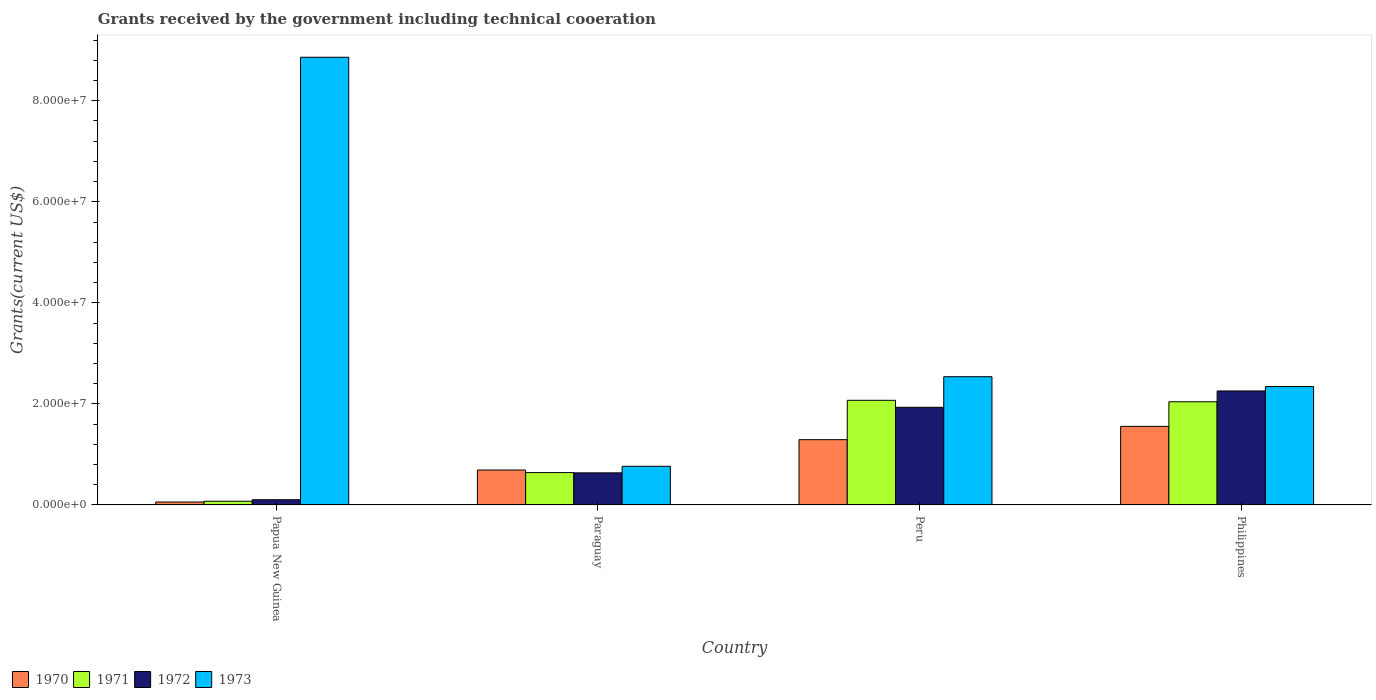How many different coloured bars are there?
Provide a succinct answer. 4. How many groups of bars are there?
Your answer should be very brief. 4. Are the number of bars per tick equal to the number of legend labels?
Your answer should be compact. Yes. How many bars are there on the 3rd tick from the right?
Offer a terse response. 4. What is the label of the 3rd group of bars from the left?
Ensure brevity in your answer.  Peru. What is the total grants received by the government in 1970 in Papua New Guinea?
Offer a terse response. 5.80e+05. Across all countries, what is the maximum total grants received by the government in 1973?
Offer a terse response. 8.86e+07. Across all countries, what is the minimum total grants received by the government in 1972?
Provide a succinct answer. 1.03e+06. In which country was the total grants received by the government in 1973 minimum?
Make the answer very short. Paraguay. What is the total total grants received by the government in 1970 in the graph?
Ensure brevity in your answer.  3.60e+07. What is the difference between the total grants received by the government in 1971 in Papua New Guinea and that in Paraguay?
Your response must be concise. -5.67e+06. What is the difference between the total grants received by the government in 1970 in Paraguay and the total grants received by the government in 1972 in Papua New Guinea?
Offer a terse response. 5.88e+06. What is the average total grants received by the government in 1971 per country?
Provide a short and direct response. 1.21e+07. What is the ratio of the total grants received by the government in 1970 in Paraguay to that in Peru?
Keep it short and to the point. 0.53. Is the total grants received by the government in 1973 in Paraguay less than that in Philippines?
Ensure brevity in your answer.  Yes. What is the difference between the highest and the second highest total grants received by the government in 1971?
Offer a very short reply. 1.43e+07. What is the difference between the highest and the lowest total grants received by the government in 1970?
Your response must be concise. 1.50e+07. Is the sum of the total grants received by the government in 1970 in Papua New Guinea and Peru greater than the maximum total grants received by the government in 1973 across all countries?
Ensure brevity in your answer.  No. What does the 2nd bar from the right in Paraguay represents?
Provide a succinct answer. 1972. Is it the case that in every country, the sum of the total grants received by the government in 1970 and total grants received by the government in 1971 is greater than the total grants received by the government in 1972?
Offer a terse response. Yes. How many countries are there in the graph?
Offer a very short reply. 4. Are the values on the major ticks of Y-axis written in scientific E-notation?
Give a very brief answer. Yes. Where does the legend appear in the graph?
Keep it short and to the point. Bottom left. How many legend labels are there?
Offer a very short reply. 4. What is the title of the graph?
Provide a short and direct response. Grants received by the government including technical cooeration. Does "1975" appear as one of the legend labels in the graph?
Provide a succinct answer. No. What is the label or title of the X-axis?
Provide a succinct answer. Country. What is the label or title of the Y-axis?
Give a very brief answer. Grants(current US$). What is the Grants(current US$) of 1970 in Papua New Guinea?
Your answer should be very brief. 5.80e+05. What is the Grants(current US$) of 1971 in Papua New Guinea?
Provide a short and direct response. 7.30e+05. What is the Grants(current US$) in 1972 in Papua New Guinea?
Ensure brevity in your answer.  1.03e+06. What is the Grants(current US$) of 1973 in Papua New Guinea?
Ensure brevity in your answer.  8.86e+07. What is the Grants(current US$) of 1970 in Paraguay?
Give a very brief answer. 6.91e+06. What is the Grants(current US$) of 1971 in Paraguay?
Your answer should be very brief. 6.40e+06. What is the Grants(current US$) in 1972 in Paraguay?
Ensure brevity in your answer.  6.35e+06. What is the Grants(current US$) in 1973 in Paraguay?
Provide a succinct answer. 7.65e+06. What is the Grants(current US$) of 1970 in Peru?
Your answer should be compact. 1.29e+07. What is the Grants(current US$) in 1971 in Peru?
Your answer should be compact. 2.07e+07. What is the Grants(current US$) in 1972 in Peru?
Your response must be concise. 1.93e+07. What is the Grants(current US$) in 1973 in Peru?
Keep it short and to the point. 2.54e+07. What is the Grants(current US$) of 1970 in Philippines?
Your response must be concise. 1.56e+07. What is the Grants(current US$) of 1971 in Philippines?
Ensure brevity in your answer.  2.04e+07. What is the Grants(current US$) in 1972 in Philippines?
Offer a very short reply. 2.26e+07. What is the Grants(current US$) of 1973 in Philippines?
Provide a succinct answer. 2.34e+07. Across all countries, what is the maximum Grants(current US$) in 1970?
Offer a terse response. 1.56e+07. Across all countries, what is the maximum Grants(current US$) in 1971?
Your answer should be very brief. 2.07e+07. Across all countries, what is the maximum Grants(current US$) of 1972?
Give a very brief answer. 2.26e+07. Across all countries, what is the maximum Grants(current US$) in 1973?
Your response must be concise. 8.86e+07. Across all countries, what is the minimum Grants(current US$) of 1970?
Keep it short and to the point. 5.80e+05. Across all countries, what is the minimum Grants(current US$) of 1971?
Offer a very short reply. 7.30e+05. Across all countries, what is the minimum Grants(current US$) in 1972?
Make the answer very short. 1.03e+06. Across all countries, what is the minimum Grants(current US$) in 1973?
Your answer should be compact. 7.65e+06. What is the total Grants(current US$) of 1970 in the graph?
Offer a terse response. 3.60e+07. What is the total Grants(current US$) of 1971 in the graph?
Your answer should be very brief. 4.83e+07. What is the total Grants(current US$) of 1972 in the graph?
Offer a very short reply. 4.93e+07. What is the total Grants(current US$) in 1973 in the graph?
Your answer should be compact. 1.45e+08. What is the difference between the Grants(current US$) of 1970 in Papua New Guinea and that in Paraguay?
Give a very brief answer. -6.33e+06. What is the difference between the Grants(current US$) in 1971 in Papua New Guinea and that in Paraguay?
Your response must be concise. -5.67e+06. What is the difference between the Grants(current US$) of 1972 in Papua New Guinea and that in Paraguay?
Make the answer very short. -5.32e+06. What is the difference between the Grants(current US$) of 1973 in Papua New Guinea and that in Paraguay?
Provide a short and direct response. 8.10e+07. What is the difference between the Grants(current US$) of 1970 in Papua New Guinea and that in Peru?
Ensure brevity in your answer.  -1.23e+07. What is the difference between the Grants(current US$) of 1971 in Papua New Guinea and that in Peru?
Offer a very short reply. -2.00e+07. What is the difference between the Grants(current US$) of 1972 in Papua New Guinea and that in Peru?
Offer a very short reply. -1.83e+07. What is the difference between the Grants(current US$) of 1973 in Papua New Guinea and that in Peru?
Offer a terse response. 6.32e+07. What is the difference between the Grants(current US$) of 1970 in Papua New Guinea and that in Philippines?
Ensure brevity in your answer.  -1.50e+07. What is the difference between the Grants(current US$) of 1971 in Papua New Guinea and that in Philippines?
Provide a short and direct response. -1.97e+07. What is the difference between the Grants(current US$) of 1972 in Papua New Guinea and that in Philippines?
Offer a very short reply. -2.15e+07. What is the difference between the Grants(current US$) in 1973 in Papua New Guinea and that in Philippines?
Ensure brevity in your answer.  6.52e+07. What is the difference between the Grants(current US$) in 1970 in Paraguay and that in Peru?
Keep it short and to the point. -6.01e+06. What is the difference between the Grants(current US$) of 1971 in Paraguay and that in Peru?
Your answer should be compact. -1.43e+07. What is the difference between the Grants(current US$) of 1972 in Paraguay and that in Peru?
Your answer should be compact. -1.30e+07. What is the difference between the Grants(current US$) of 1973 in Paraguay and that in Peru?
Give a very brief answer. -1.77e+07. What is the difference between the Grants(current US$) in 1970 in Paraguay and that in Philippines?
Provide a succinct answer. -8.64e+06. What is the difference between the Grants(current US$) in 1971 in Paraguay and that in Philippines?
Provide a short and direct response. -1.40e+07. What is the difference between the Grants(current US$) of 1972 in Paraguay and that in Philippines?
Offer a very short reply. -1.62e+07. What is the difference between the Grants(current US$) in 1973 in Paraguay and that in Philippines?
Provide a succinct answer. -1.58e+07. What is the difference between the Grants(current US$) of 1970 in Peru and that in Philippines?
Keep it short and to the point. -2.63e+06. What is the difference between the Grants(current US$) of 1971 in Peru and that in Philippines?
Offer a terse response. 2.90e+05. What is the difference between the Grants(current US$) in 1972 in Peru and that in Philippines?
Ensure brevity in your answer.  -3.24e+06. What is the difference between the Grants(current US$) of 1973 in Peru and that in Philippines?
Your answer should be very brief. 1.95e+06. What is the difference between the Grants(current US$) of 1970 in Papua New Guinea and the Grants(current US$) of 1971 in Paraguay?
Your answer should be very brief. -5.82e+06. What is the difference between the Grants(current US$) of 1970 in Papua New Guinea and the Grants(current US$) of 1972 in Paraguay?
Your answer should be compact. -5.77e+06. What is the difference between the Grants(current US$) of 1970 in Papua New Guinea and the Grants(current US$) of 1973 in Paraguay?
Keep it short and to the point. -7.07e+06. What is the difference between the Grants(current US$) in 1971 in Papua New Guinea and the Grants(current US$) in 1972 in Paraguay?
Your answer should be very brief. -5.62e+06. What is the difference between the Grants(current US$) of 1971 in Papua New Guinea and the Grants(current US$) of 1973 in Paraguay?
Ensure brevity in your answer.  -6.92e+06. What is the difference between the Grants(current US$) in 1972 in Papua New Guinea and the Grants(current US$) in 1973 in Paraguay?
Your answer should be very brief. -6.62e+06. What is the difference between the Grants(current US$) in 1970 in Papua New Guinea and the Grants(current US$) in 1971 in Peru?
Offer a very short reply. -2.01e+07. What is the difference between the Grants(current US$) of 1970 in Papua New Guinea and the Grants(current US$) of 1972 in Peru?
Provide a succinct answer. -1.87e+07. What is the difference between the Grants(current US$) in 1970 in Papua New Guinea and the Grants(current US$) in 1973 in Peru?
Offer a very short reply. -2.48e+07. What is the difference between the Grants(current US$) of 1971 in Papua New Guinea and the Grants(current US$) of 1972 in Peru?
Ensure brevity in your answer.  -1.86e+07. What is the difference between the Grants(current US$) of 1971 in Papua New Guinea and the Grants(current US$) of 1973 in Peru?
Keep it short and to the point. -2.46e+07. What is the difference between the Grants(current US$) of 1972 in Papua New Guinea and the Grants(current US$) of 1973 in Peru?
Keep it short and to the point. -2.44e+07. What is the difference between the Grants(current US$) in 1970 in Papua New Guinea and the Grants(current US$) in 1971 in Philippines?
Ensure brevity in your answer.  -1.98e+07. What is the difference between the Grants(current US$) in 1970 in Papua New Guinea and the Grants(current US$) in 1972 in Philippines?
Make the answer very short. -2.20e+07. What is the difference between the Grants(current US$) of 1970 in Papua New Guinea and the Grants(current US$) of 1973 in Philippines?
Your answer should be compact. -2.28e+07. What is the difference between the Grants(current US$) in 1971 in Papua New Guinea and the Grants(current US$) in 1972 in Philippines?
Your response must be concise. -2.18e+07. What is the difference between the Grants(current US$) of 1971 in Papua New Guinea and the Grants(current US$) of 1973 in Philippines?
Ensure brevity in your answer.  -2.27e+07. What is the difference between the Grants(current US$) of 1972 in Papua New Guinea and the Grants(current US$) of 1973 in Philippines?
Provide a succinct answer. -2.24e+07. What is the difference between the Grants(current US$) of 1970 in Paraguay and the Grants(current US$) of 1971 in Peru?
Your answer should be very brief. -1.38e+07. What is the difference between the Grants(current US$) of 1970 in Paraguay and the Grants(current US$) of 1972 in Peru?
Provide a succinct answer. -1.24e+07. What is the difference between the Grants(current US$) in 1970 in Paraguay and the Grants(current US$) in 1973 in Peru?
Your answer should be very brief. -1.85e+07. What is the difference between the Grants(current US$) in 1971 in Paraguay and the Grants(current US$) in 1972 in Peru?
Make the answer very short. -1.29e+07. What is the difference between the Grants(current US$) of 1971 in Paraguay and the Grants(current US$) of 1973 in Peru?
Provide a short and direct response. -1.90e+07. What is the difference between the Grants(current US$) of 1972 in Paraguay and the Grants(current US$) of 1973 in Peru?
Make the answer very short. -1.90e+07. What is the difference between the Grants(current US$) in 1970 in Paraguay and the Grants(current US$) in 1971 in Philippines?
Give a very brief answer. -1.35e+07. What is the difference between the Grants(current US$) of 1970 in Paraguay and the Grants(current US$) of 1972 in Philippines?
Ensure brevity in your answer.  -1.56e+07. What is the difference between the Grants(current US$) of 1970 in Paraguay and the Grants(current US$) of 1973 in Philippines?
Ensure brevity in your answer.  -1.65e+07. What is the difference between the Grants(current US$) of 1971 in Paraguay and the Grants(current US$) of 1972 in Philippines?
Offer a terse response. -1.62e+07. What is the difference between the Grants(current US$) of 1971 in Paraguay and the Grants(current US$) of 1973 in Philippines?
Offer a terse response. -1.70e+07. What is the difference between the Grants(current US$) of 1972 in Paraguay and the Grants(current US$) of 1973 in Philippines?
Offer a terse response. -1.71e+07. What is the difference between the Grants(current US$) in 1970 in Peru and the Grants(current US$) in 1971 in Philippines?
Offer a very short reply. -7.50e+06. What is the difference between the Grants(current US$) in 1970 in Peru and the Grants(current US$) in 1972 in Philippines?
Provide a succinct answer. -9.64e+06. What is the difference between the Grants(current US$) of 1970 in Peru and the Grants(current US$) of 1973 in Philippines?
Offer a terse response. -1.05e+07. What is the difference between the Grants(current US$) of 1971 in Peru and the Grants(current US$) of 1972 in Philippines?
Your response must be concise. -1.85e+06. What is the difference between the Grants(current US$) in 1971 in Peru and the Grants(current US$) in 1973 in Philippines?
Provide a short and direct response. -2.72e+06. What is the difference between the Grants(current US$) in 1972 in Peru and the Grants(current US$) in 1973 in Philippines?
Make the answer very short. -4.11e+06. What is the average Grants(current US$) in 1970 per country?
Your answer should be compact. 8.99e+06. What is the average Grants(current US$) of 1971 per country?
Provide a short and direct response. 1.21e+07. What is the average Grants(current US$) in 1972 per country?
Keep it short and to the point. 1.23e+07. What is the average Grants(current US$) of 1973 per country?
Provide a short and direct response. 3.63e+07. What is the difference between the Grants(current US$) of 1970 and Grants(current US$) of 1972 in Papua New Guinea?
Give a very brief answer. -4.50e+05. What is the difference between the Grants(current US$) in 1970 and Grants(current US$) in 1973 in Papua New Guinea?
Your answer should be compact. -8.80e+07. What is the difference between the Grants(current US$) in 1971 and Grants(current US$) in 1973 in Papua New Guinea?
Offer a terse response. -8.79e+07. What is the difference between the Grants(current US$) of 1972 and Grants(current US$) of 1973 in Papua New Guinea?
Provide a succinct answer. -8.76e+07. What is the difference between the Grants(current US$) of 1970 and Grants(current US$) of 1971 in Paraguay?
Keep it short and to the point. 5.10e+05. What is the difference between the Grants(current US$) of 1970 and Grants(current US$) of 1972 in Paraguay?
Your answer should be compact. 5.60e+05. What is the difference between the Grants(current US$) of 1970 and Grants(current US$) of 1973 in Paraguay?
Your response must be concise. -7.40e+05. What is the difference between the Grants(current US$) of 1971 and Grants(current US$) of 1973 in Paraguay?
Offer a very short reply. -1.25e+06. What is the difference between the Grants(current US$) in 1972 and Grants(current US$) in 1973 in Paraguay?
Your answer should be very brief. -1.30e+06. What is the difference between the Grants(current US$) in 1970 and Grants(current US$) in 1971 in Peru?
Your answer should be compact. -7.79e+06. What is the difference between the Grants(current US$) of 1970 and Grants(current US$) of 1972 in Peru?
Provide a short and direct response. -6.40e+06. What is the difference between the Grants(current US$) of 1970 and Grants(current US$) of 1973 in Peru?
Give a very brief answer. -1.25e+07. What is the difference between the Grants(current US$) of 1971 and Grants(current US$) of 1972 in Peru?
Ensure brevity in your answer.  1.39e+06. What is the difference between the Grants(current US$) in 1971 and Grants(current US$) in 1973 in Peru?
Keep it short and to the point. -4.67e+06. What is the difference between the Grants(current US$) of 1972 and Grants(current US$) of 1973 in Peru?
Offer a very short reply. -6.06e+06. What is the difference between the Grants(current US$) in 1970 and Grants(current US$) in 1971 in Philippines?
Offer a terse response. -4.87e+06. What is the difference between the Grants(current US$) of 1970 and Grants(current US$) of 1972 in Philippines?
Provide a short and direct response. -7.01e+06. What is the difference between the Grants(current US$) of 1970 and Grants(current US$) of 1973 in Philippines?
Offer a very short reply. -7.88e+06. What is the difference between the Grants(current US$) of 1971 and Grants(current US$) of 1972 in Philippines?
Make the answer very short. -2.14e+06. What is the difference between the Grants(current US$) of 1971 and Grants(current US$) of 1973 in Philippines?
Your response must be concise. -3.01e+06. What is the difference between the Grants(current US$) in 1972 and Grants(current US$) in 1973 in Philippines?
Offer a terse response. -8.70e+05. What is the ratio of the Grants(current US$) of 1970 in Papua New Guinea to that in Paraguay?
Provide a short and direct response. 0.08. What is the ratio of the Grants(current US$) in 1971 in Papua New Guinea to that in Paraguay?
Make the answer very short. 0.11. What is the ratio of the Grants(current US$) in 1972 in Papua New Guinea to that in Paraguay?
Keep it short and to the point. 0.16. What is the ratio of the Grants(current US$) in 1973 in Papua New Guinea to that in Paraguay?
Your answer should be very brief. 11.58. What is the ratio of the Grants(current US$) of 1970 in Papua New Guinea to that in Peru?
Your answer should be compact. 0.04. What is the ratio of the Grants(current US$) in 1971 in Papua New Guinea to that in Peru?
Your answer should be compact. 0.04. What is the ratio of the Grants(current US$) of 1972 in Papua New Guinea to that in Peru?
Provide a short and direct response. 0.05. What is the ratio of the Grants(current US$) in 1973 in Papua New Guinea to that in Peru?
Ensure brevity in your answer.  3.49. What is the ratio of the Grants(current US$) in 1970 in Papua New Guinea to that in Philippines?
Your answer should be very brief. 0.04. What is the ratio of the Grants(current US$) in 1971 in Papua New Guinea to that in Philippines?
Offer a very short reply. 0.04. What is the ratio of the Grants(current US$) of 1972 in Papua New Guinea to that in Philippines?
Your response must be concise. 0.05. What is the ratio of the Grants(current US$) in 1973 in Papua New Guinea to that in Philippines?
Your answer should be very brief. 3.78. What is the ratio of the Grants(current US$) of 1970 in Paraguay to that in Peru?
Your answer should be very brief. 0.53. What is the ratio of the Grants(current US$) of 1971 in Paraguay to that in Peru?
Give a very brief answer. 0.31. What is the ratio of the Grants(current US$) of 1972 in Paraguay to that in Peru?
Keep it short and to the point. 0.33. What is the ratio of the Grants(current US$) in 1973 in Paraguay to that in Peru?
Offer a very short reply. 0.3. What is the ratio of the Grants(current US$) of 1970 in Paraguay to that in Philippines?
Provide a short and direct response. 0.44. What is the ratio of the Grants(current US$) of 1971 in Paraguay to that in Philippines?
Offer a very short reply. 0.31. What is the ratio of the Grants(current US$) in 1972 in Paraguay to that in Philippines?
Keep it short and to the point. 0.28. What is the ratio of the Grants(current US$) of 1973 in Paraguay to that in Philippines?
Provide a succinct answer. 0.33. What is the ratio of the Grants(current US$) of 1970 in Peru to that in Philippines?
Offer a very short reply. 0.83. What is the ratio of the Grants(current US$) in 1971 in Peru to that in Philippines?
Make the answer very short. 1.01. What is the ratio of the Grants(current US$) of 1972 in Peru to that in Philippines?
Keep it short and to the point. 0.86. What is the ratio of the Grants(current US$) of 1973 in Peru to that in Philippines?
Make the answer very short. 1.08. What is the difference between the highest and the second highest Grants(current US$) of 1970?
Make the answer very short. 2.63e+06. What is the difference between the highest and the second highest Grants(current US$) of 1972?
Make the answer very short. 3.24e+06. What is the difference between the highest and the second highest Grants(current US$) of 1973?
Your answer should be very brief. 6.32e+07. What is the difference between the highest and the lowest Grants(current US$) of 1970?
Your answer should be compact. 1.50e+07. What is the difference between the highest and the lowest Grants(current US$) of 1971?
Offer a terse response. 2.00e+07. What is the difference between the highest and the lowest Grants(current US$) of 1972?
Your response must be concise. 2.15e+07. What is the difference between the highest and the lowest Grants(current US$) of 1973?
Offer a terse response. 8.10e+07. 